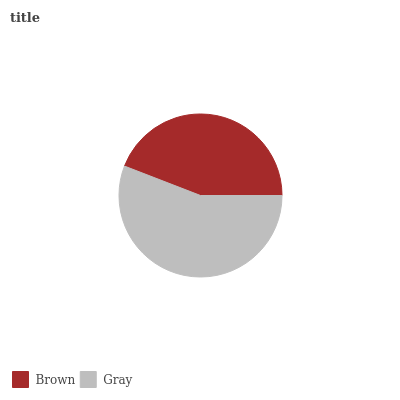Is Brown the minimum?
Answer yes or no. Yes. Is Gray the maximum?
Answer yes or no. Yes. Is Gray the minimum?
Answer yes or no. No. Is Gray greater than Brown?
Answer yes or no. Yes. Is Brown less than Gray?
Answer yes or no. Yes. Is Brown greater than Gray?
Answer yes or no. No. Is Gray less than Brown?
Answer yes or no. No. Is Gray the high median?
Answer yes or no. Yes. Is Brown the low median?
Answer yes or no. Yes. Is Brown the high median?
Answer yes or no. No. Is Gray the low median?
Answer yes or no. No. 